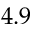Convert formula to latex. <formula><loc_0><loc_0><loc_500><loc_500>4 . 9</formula> 